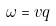Convert formula to latex. <formula><loc_0><loc_0><loc_500><loc_500>\omega = v q</formula> 